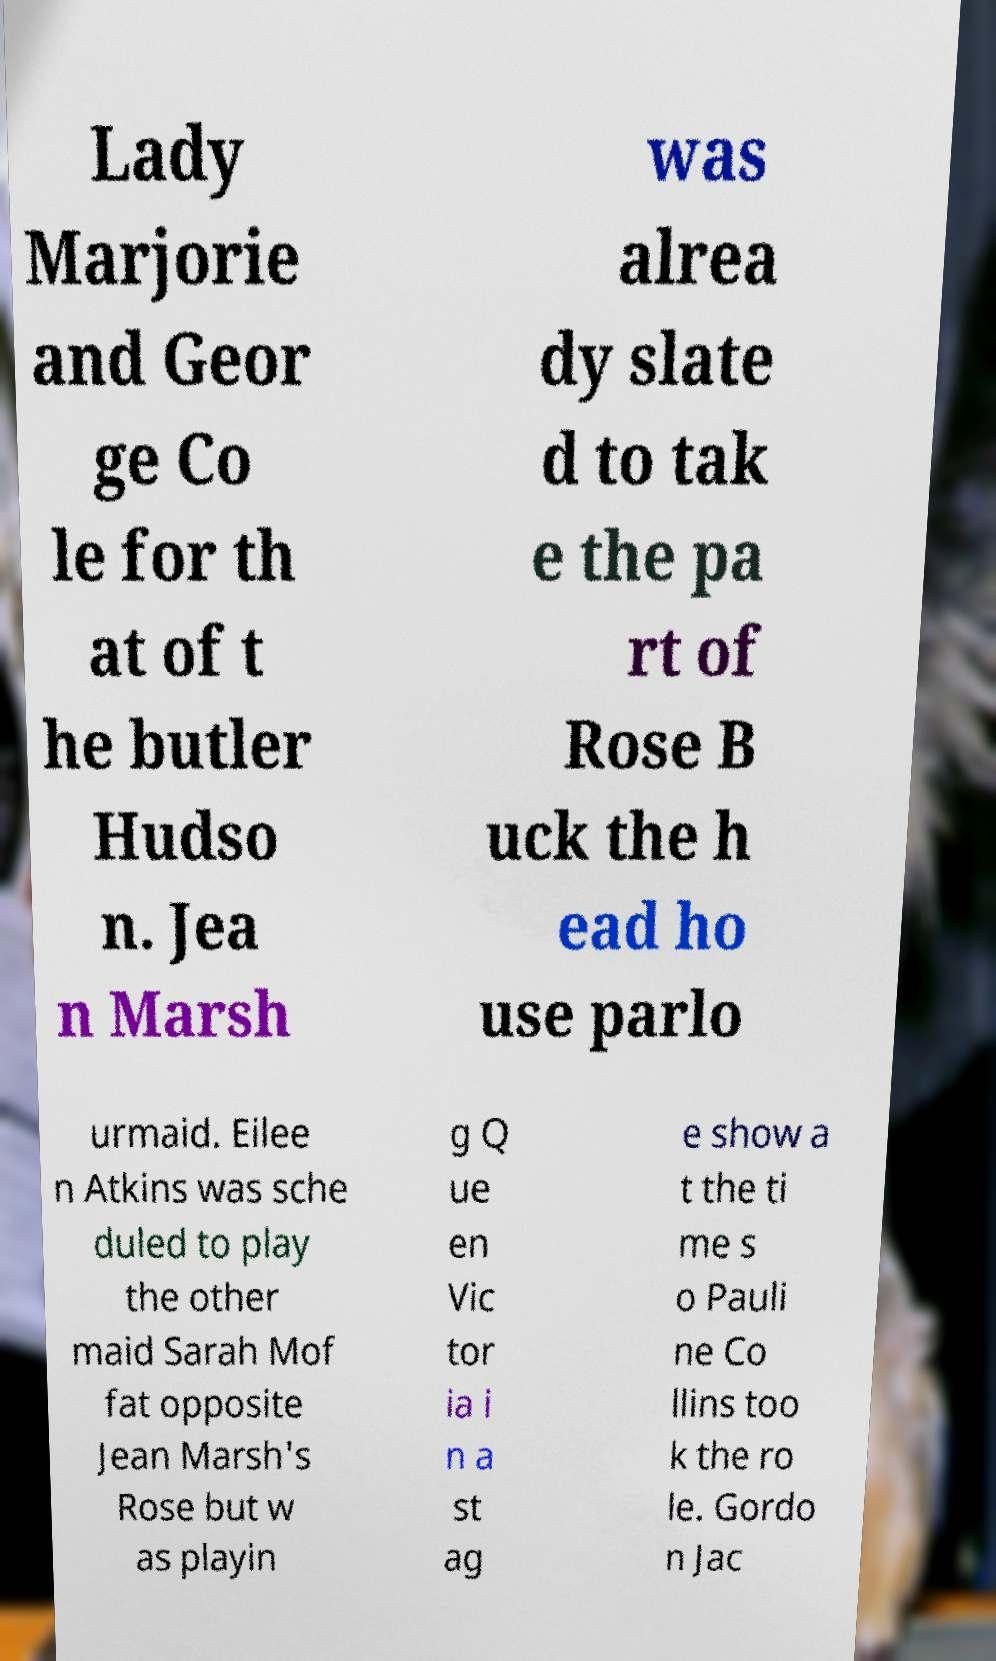Can you accurately transcribe the text from the provided image for me? Lady Marjorie and Geor ge Co le for th at of t he butler Hudso n. Jea n Marsh was alrea dy slate d to tak e the pa rt of Rose B uck the h ead ho use parlo urmaid. Eilee n Atkins was sche duled to play the other maid Sarah Mof fat opposite Jean Marsh's Rose but w as playin g Q ue en Vic tor ia i n a st ag e show a t the ti me s o Pauli ne Co llins too k the ro le. Gordo n Jac 